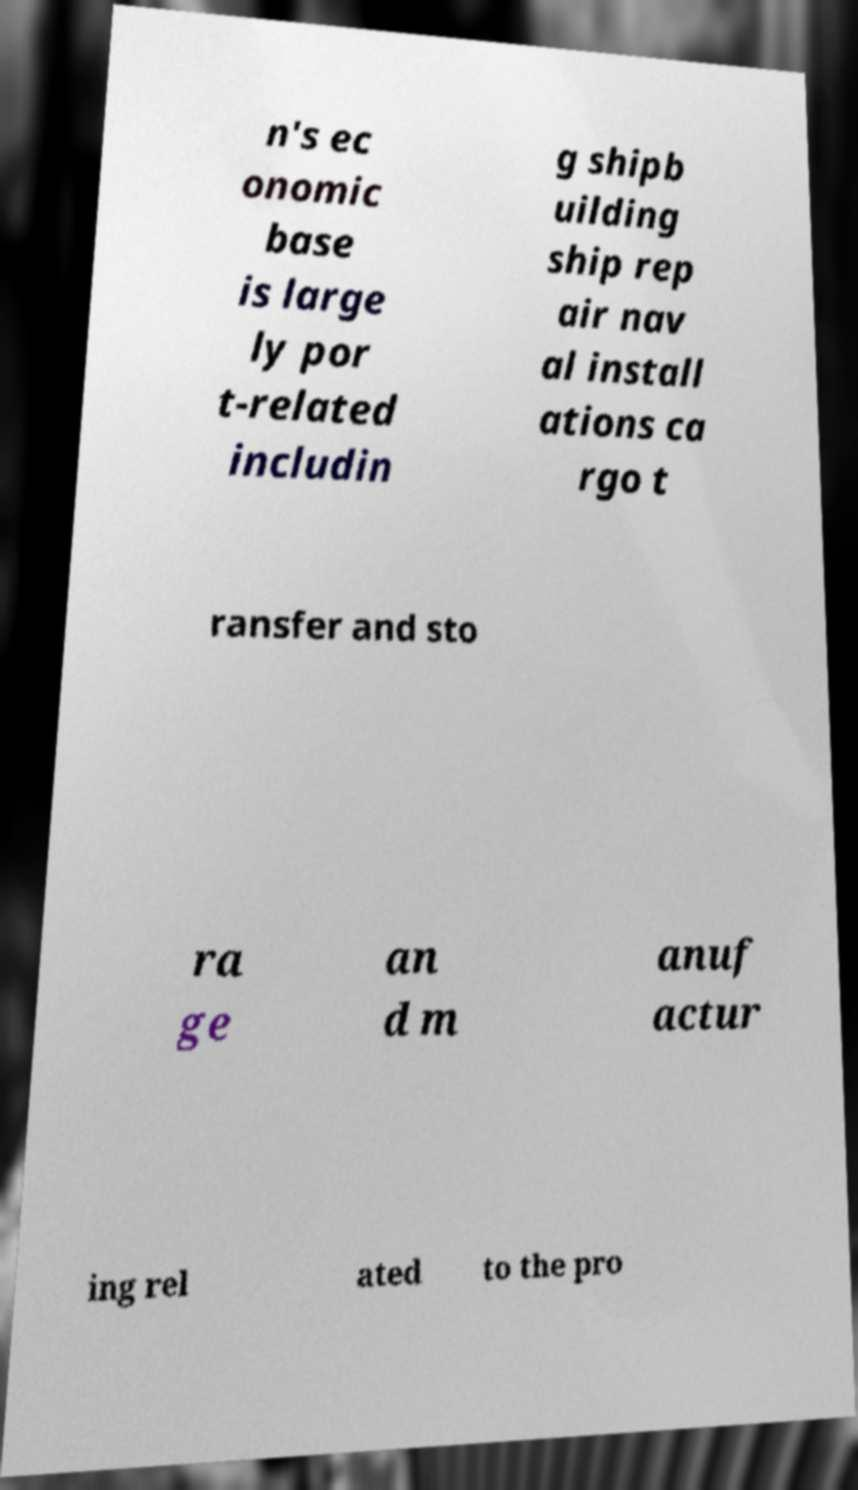Please identify and transcribe the text found in this image. n's ec onomic base is large ly por t-related includin g shipb uilding ship rep air nav al install ations ca rgo t ransfer and sto ra ge an d m anuf actur ing rel ated to the pro 